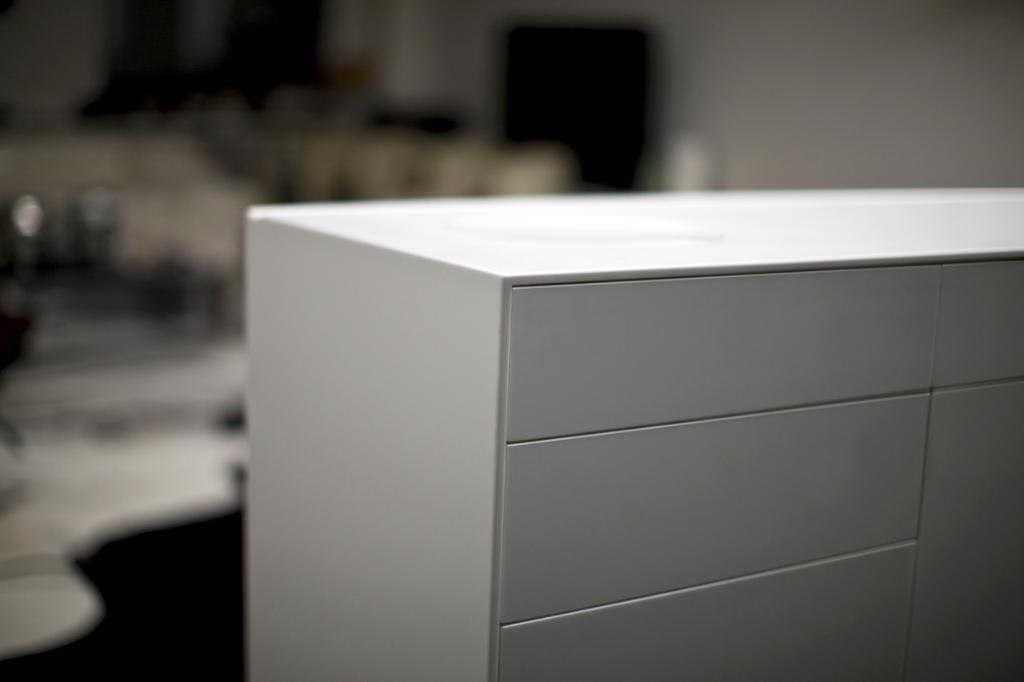In one or two sentences, can you explain what this image depicts? In this image in the foreground there is a desk, and in the background there is wall television and some other objects. 